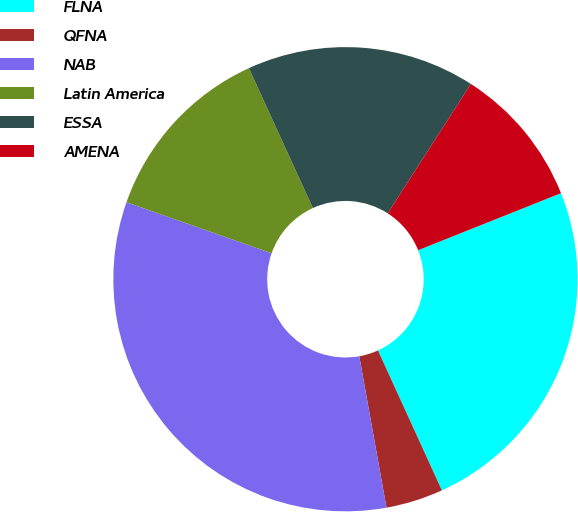Convert chart to OTSL. <chart><loc_0><loc_0><loc_500><loc_500><pie_chart><fcel>FLNA<fcel>QFNA<fcel>NAB<fcel>Latin America<fcel>ESSA<fcel>AMENA<nl><fcel>24.22%<fcel>3.99%<fcel>33.2%<fcel>12.79%<fcel>15.91%<fcel>9.87%<nl></chart> 